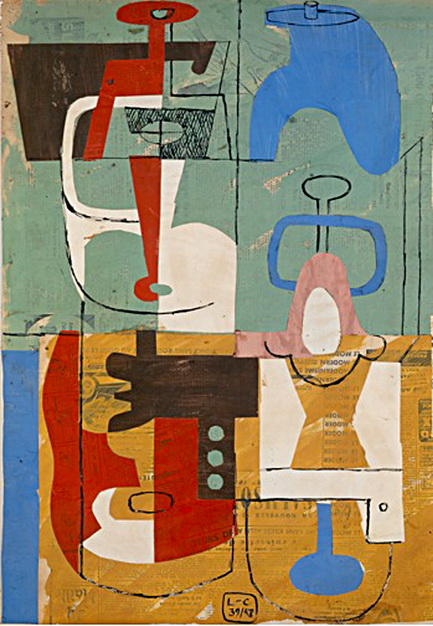Can you describe the main features of this image for me? The image is a fascinating piece of abstract art, predominantly influenced by cubism. It features a vibrant palette of colors such as blue, red, orange, and white. The artwork is divided into different sections, each with its distinct combination of shapes and colors, contributing to a rich visual complexity. The shapes primarily consist of geometric forms, including lines and curves, which provide a dynamic and engaging quality to the piece.

The artwork showcases a textured background in soothing shades of blue and green, creating a calming contrast with the more vivid foreground. The distribution and interaction of shapes and colors suggest an intricate balance and harmony within the abstract composition. This piece exemplifies the abstract art style, drawing the viewer's attention through its compelling use of form and color. 